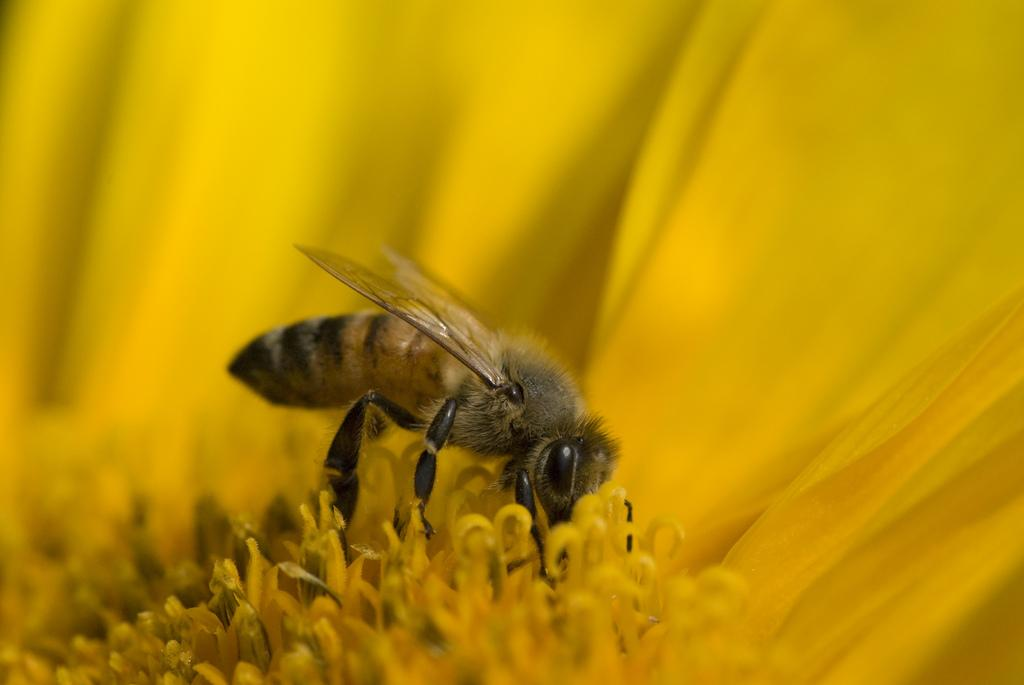What is present in the image? There is a bee in the image. What is the bee doing in the image? The bee is on a flower. Where is the bee and the flower located in the image? The bee and the flower are in the center of the image. What type of toothbrush can be seen in the image? There is no toothbrush present in the image. What color is the ink on the flower in the image? There is no ink present on the flower in the image. 